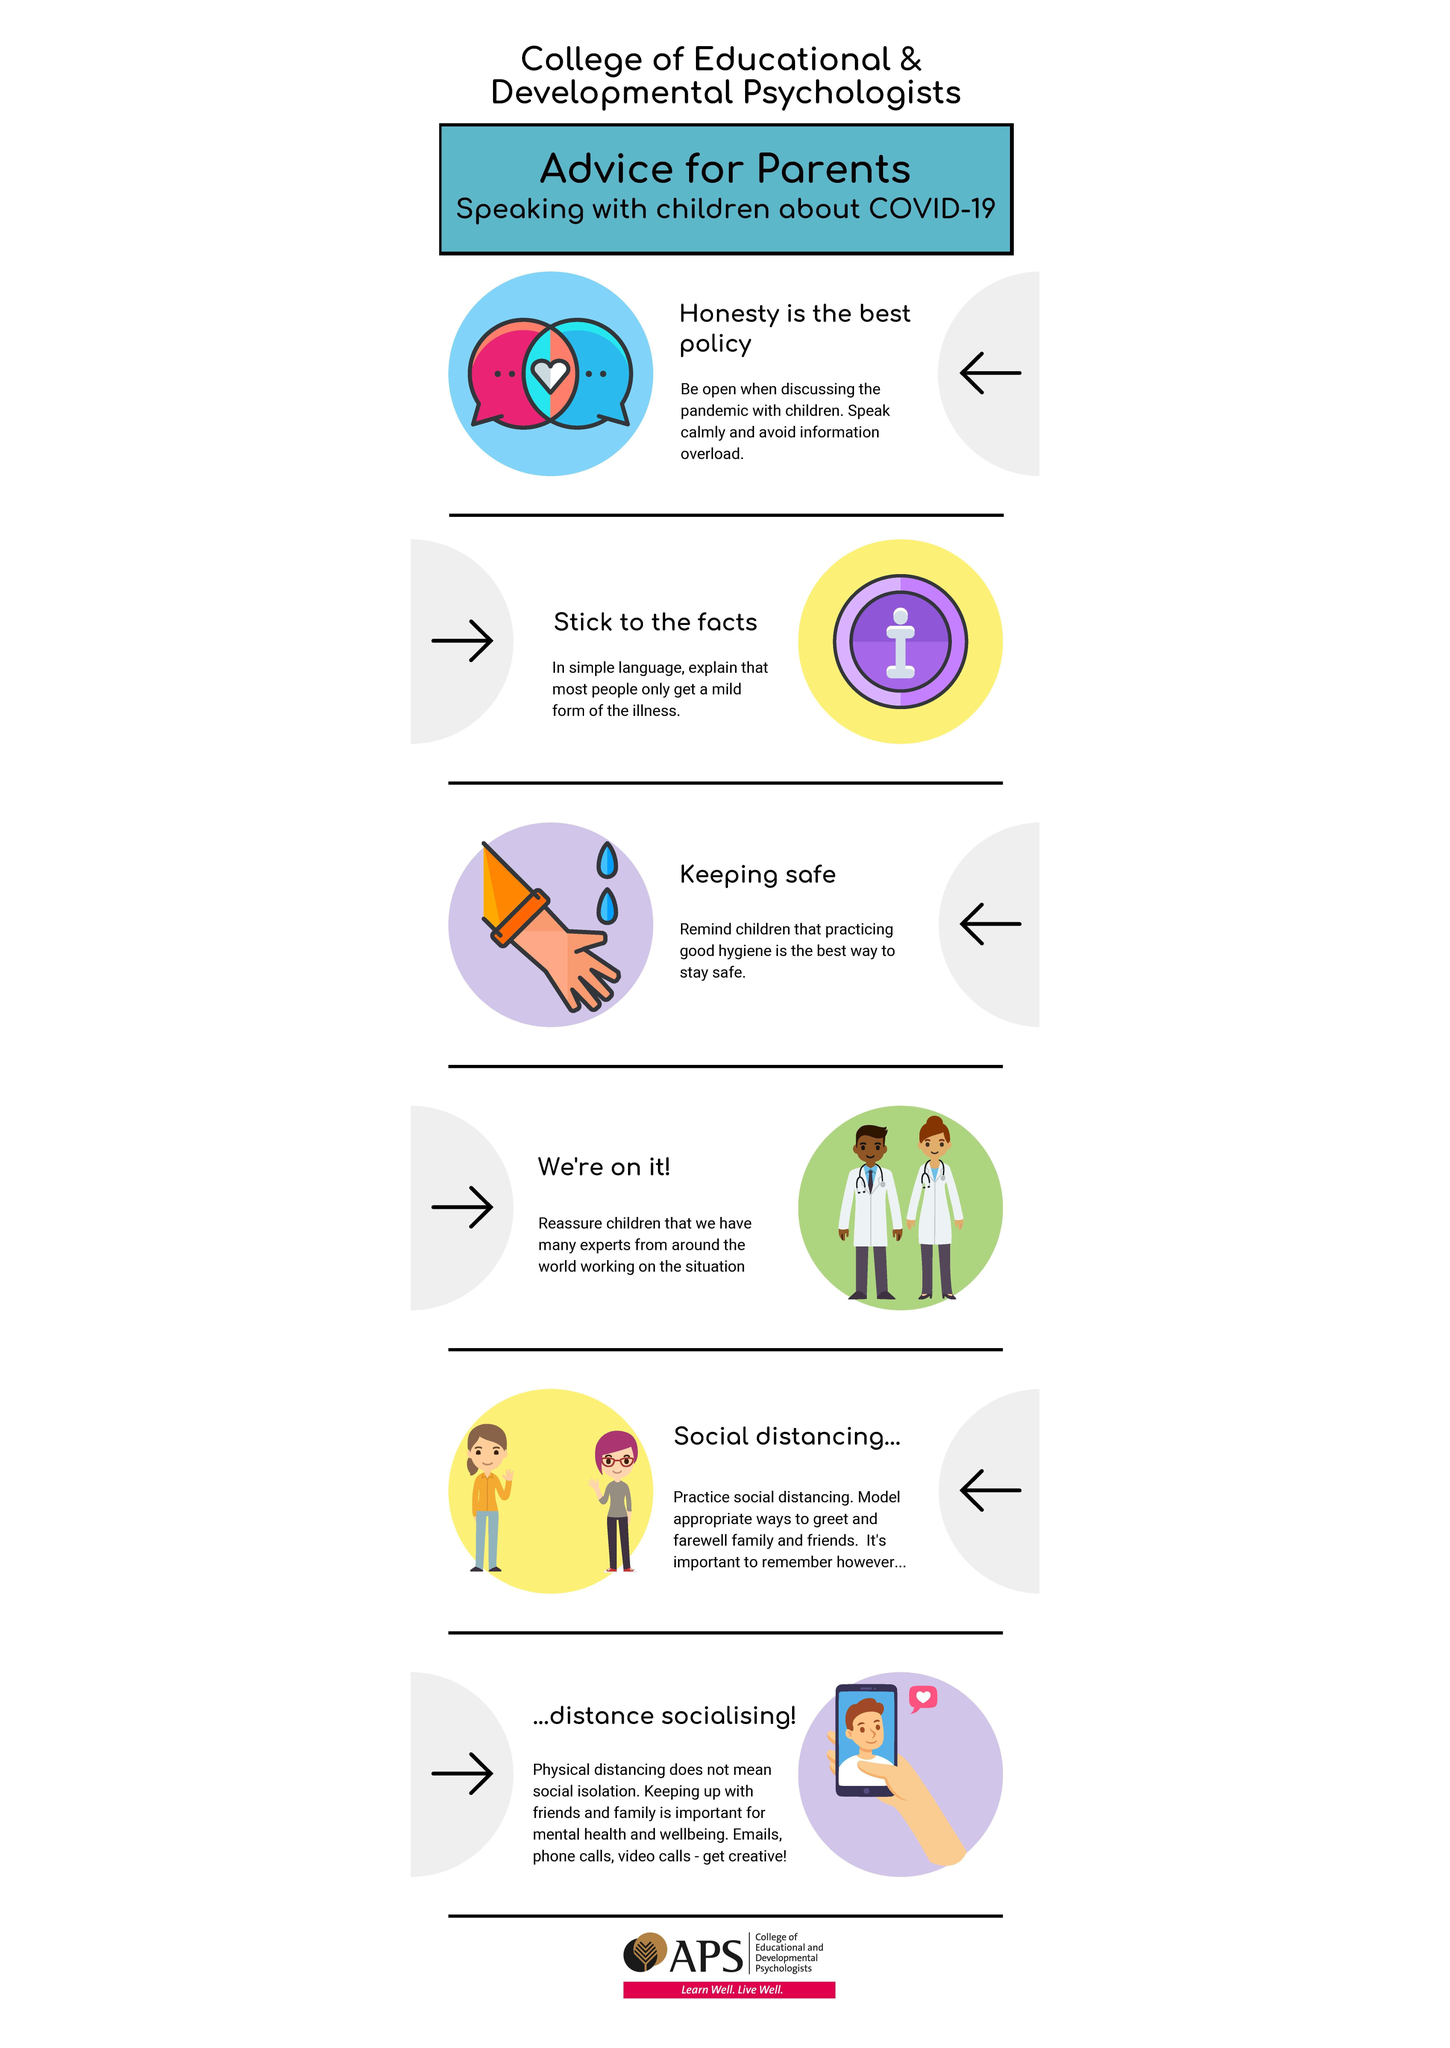What is the greatest practise to prevent corona?
Answer the question with a short phrase. practicing good hygiene 